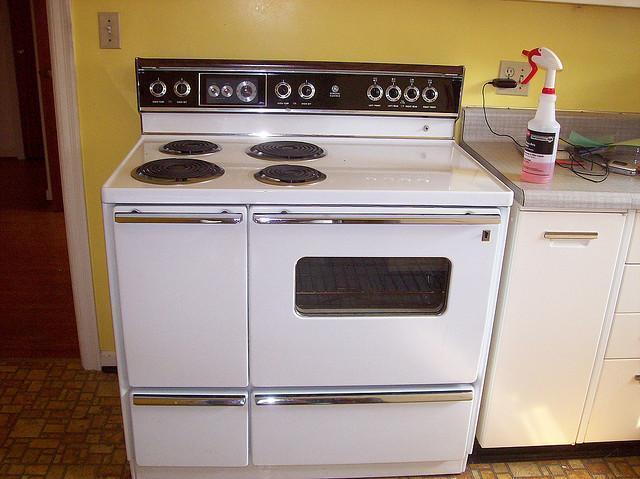How many ovens are visible?
Give a very brief answer. 1. How many bottles can you see?
Give a very brief answer. 1. 